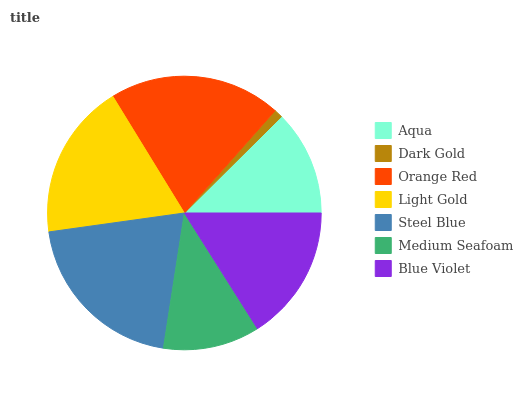Is Dark Gold the minimum?
Answer yes or no. Yes. Is Steel Blue the maximum?
Answer yes or no. Yes. Is Orange Red the minimum?
Answer yes or no. No. Is Orange Red the maximum?
Answer yes or no. No. Is Orange Red greater than Dark Gold?
Answer yes or no. Yes. Is Dark Gold less than Orange Red?
Answer yes or no. Yes. Is Dark Gold greater than Orange Red?
Answer yes or no. No. Is Orange Red less than Dark Gold?
Answer yes or no. No. Is Blue Violet the high median?
Answer yes or no. Yes. Is Blue Violet the low median?
Answer yes or no. Yes. Is Light Gold the high median?
Answer yes or no. No. Is Light Gold the low median?
Answer yes or no. No. 